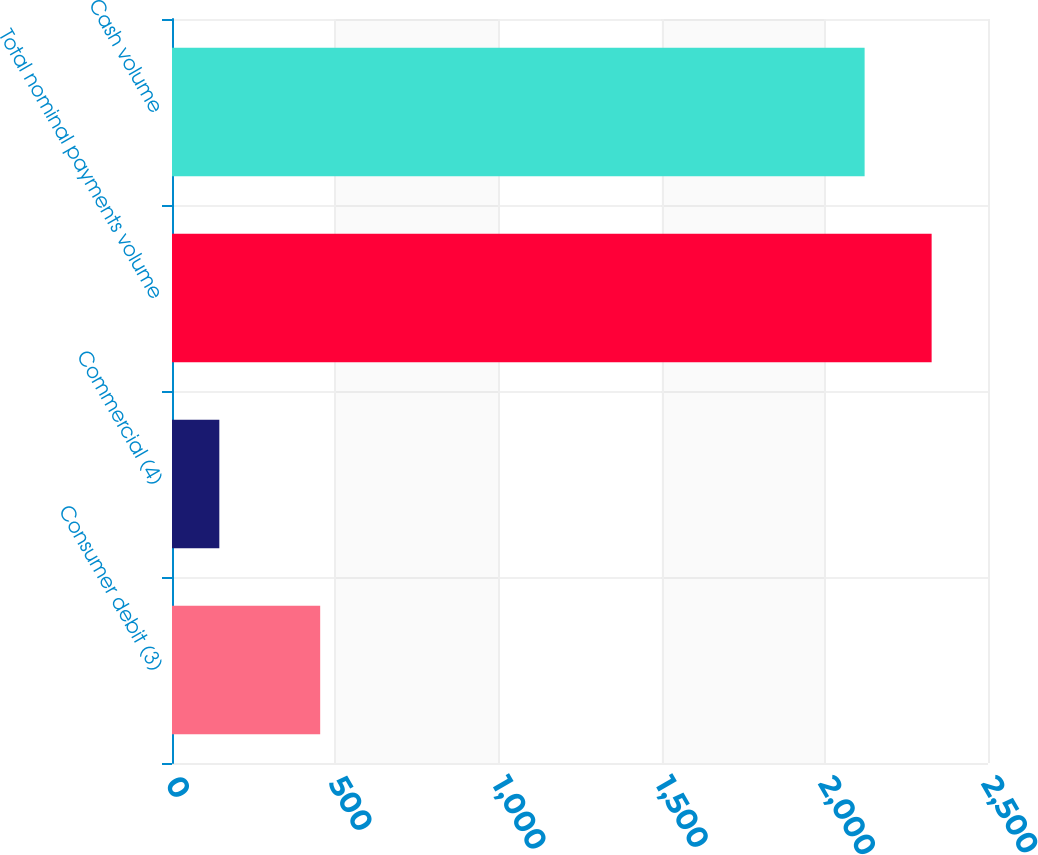Convert chart to OTSL. <chart><loc_0><loc_0><loc_500><loc_500><bar_chart><fcel>Consumer debit (3)<fcel>Commercial (4)<fcel>Total nominal payments volume<fcel>Cash volume<nl><fcel>454<fcel>145<fcel>2327.3<fcel>2122<nl></chart> 